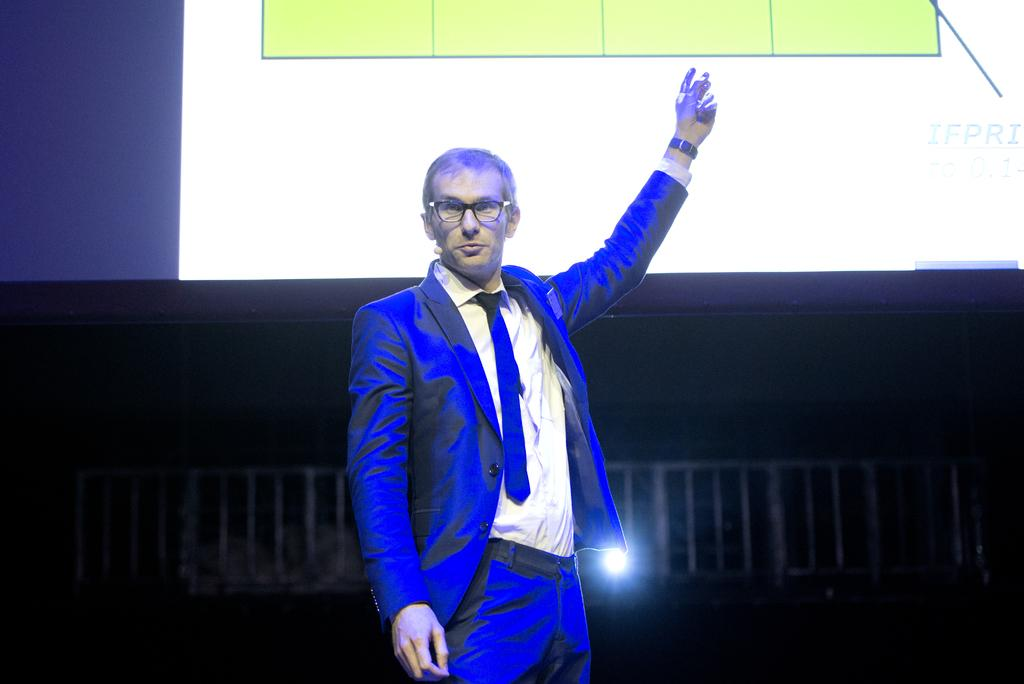What is the main subject of the image? There is a man standing in the image. What is the man wearing? The man is wearing a blazer. What can be seen in the background of the image? There is a screen in the background of the image. What type of yarn is the man using to knit in the image? There is no yarn or knitting activity present in the image; the man is simply standing and wearing a blazer. 